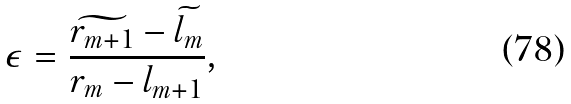Convert formula to latex. <formula><loc_0><loc_0><loc_500><loc_500>\epsilon = \frac { \widetilde { r _ { m + 1 } } - \widetilde { l _ { m } } } { r _ { m } - l _ { m + 1 } } ,</formula> 